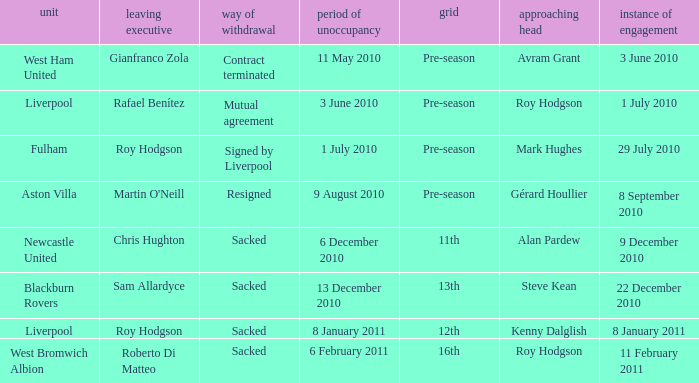What is the table for the team Blackburn Rovers? 13th. 